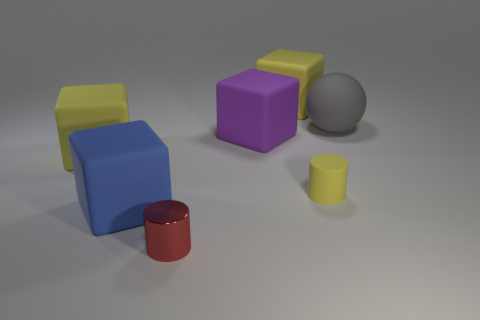Could you describe the arrangement of shapes in the image? Certainly, the shapes are arranged on a flat surface with the cubes and rectangular blocks forming an approximate arc from the foreground to the middle of the image, while the cylinders are placed at either end of this arc. The small gray shapes are positioned closely together near the center of the configuration. 